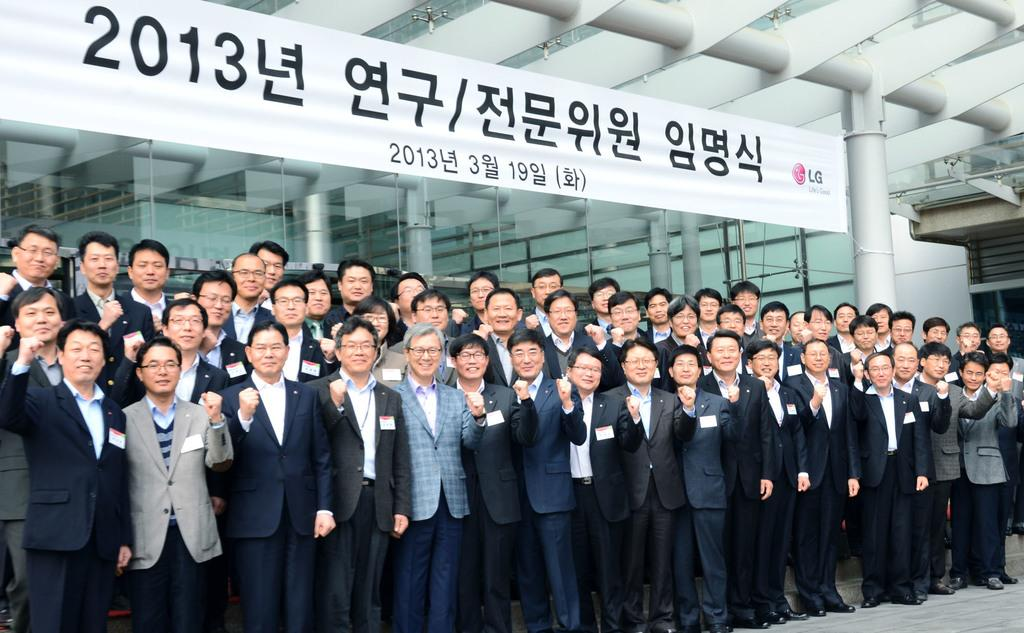What is the main subject of the image? The main subject of the image is a group of people. Where are the people located in the image? The people are standing on the floor in the image. What are the people wearing? The people are wearing suits in the image. What is the facial expression of the people? The people are smiling in the image. What else can be seen in the background of the image? There is a hoarding visible in the image. What type of produce is being carried by the porter in the image? There is no porter or produce present in the image. What color is the collar of the dog in the image? There is no dog or collar present in the image. 